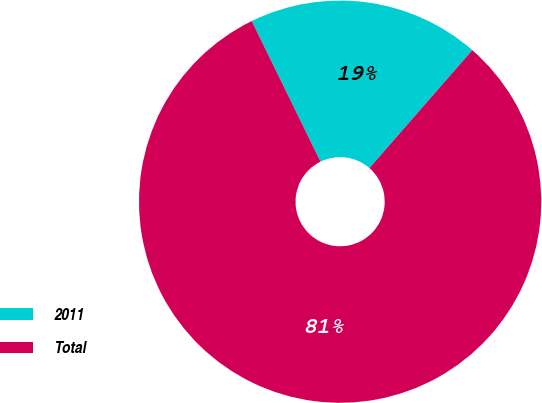Convert chart. <chart><loc_0><loc_0><loc_500><loc_500><pie_chart><fcel>2011<fcel>Total<nl><fcel>18.66%<fcel>81.34%<nl></chart> 